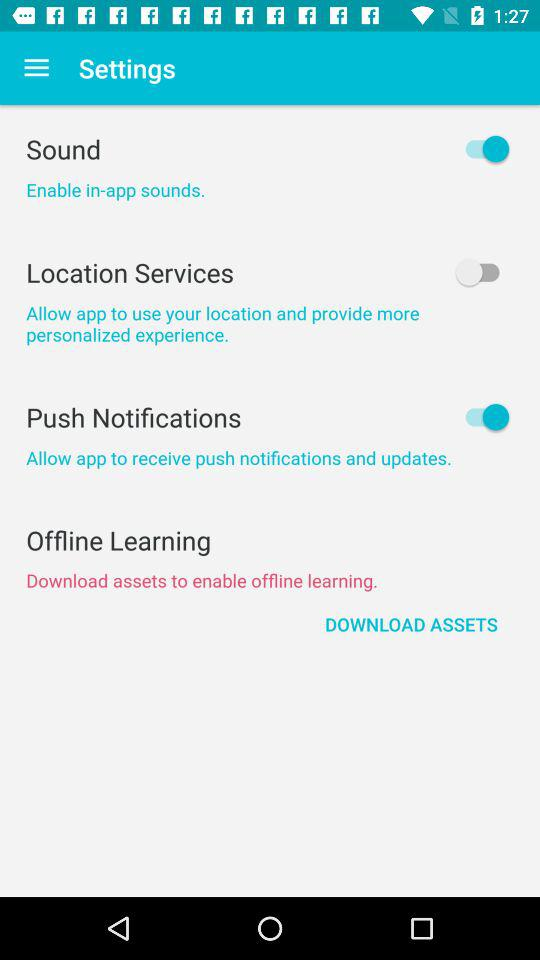What's the status of "Sound"? The status is "on". 